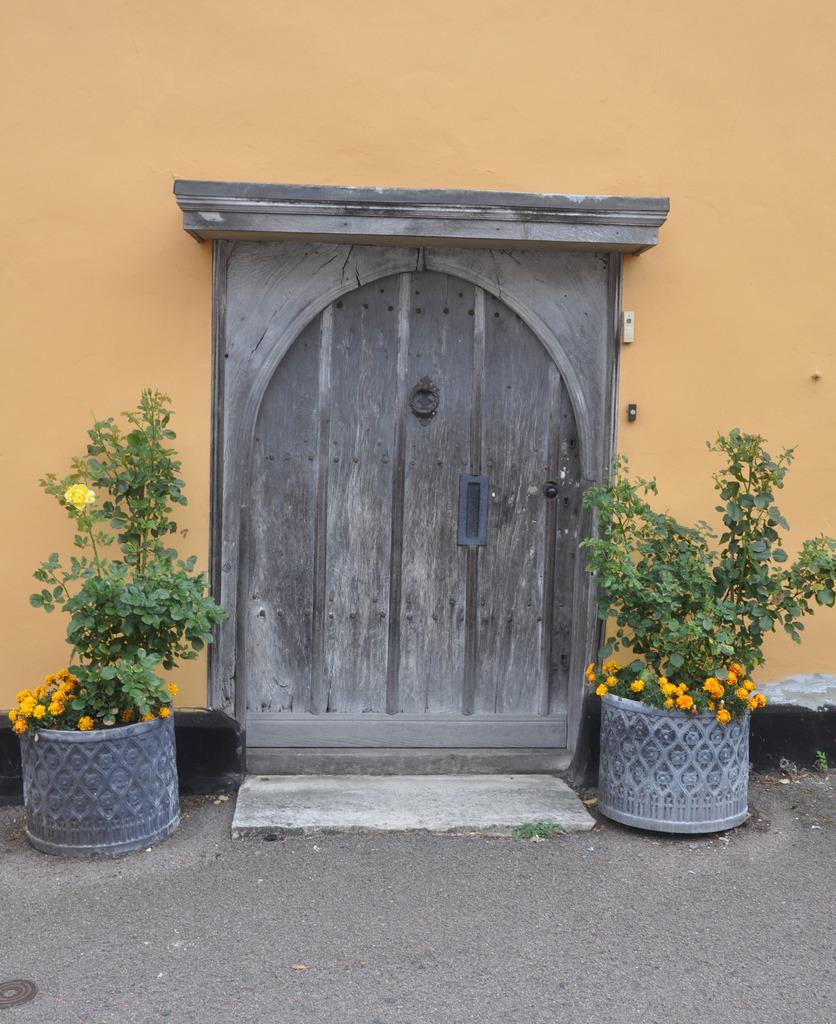Please provide a concise description of this image. In this picture we can see house plants with flowers on the ground, door, wall and some objects. 